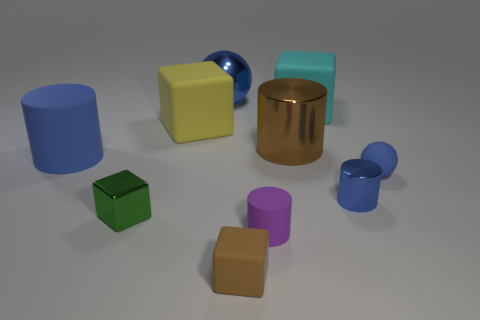Subtract all cyan spheres. How many blue cylinders are left? 2 Subtract all small blue cylinders. How many cylinders are left? 3 Subtract all yellow blocks. How many blocks are left? 3 Subtract all green blocks. Subtract all cyan balls. How many blocks are left? 3 Subtract all cubes. How many objects are left? 6 Subtract all large spheres. Subtract all big metallic objects. How many objects are left? 7 Add 4 big blocks. How many big blocks are left? 6 Add 9 purple blocks. How many purple blocks exist? 9 Subtract 0 yellow cylinders. How many objects are left? 10 